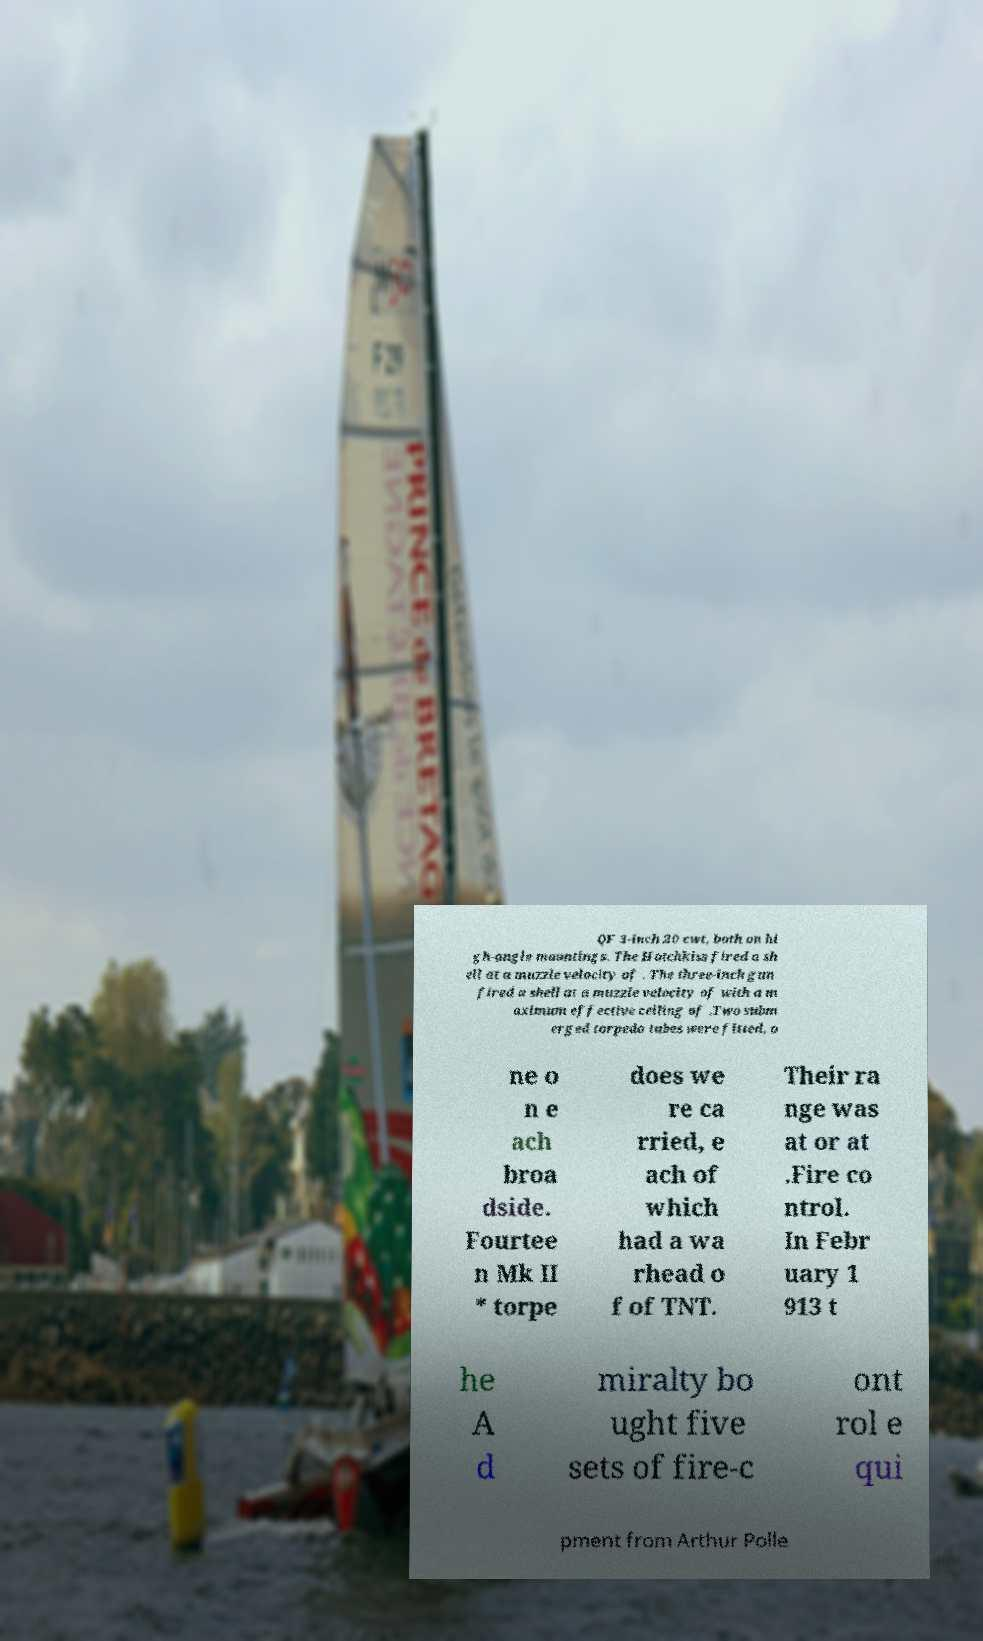I need the written content from this picture converted into text. Can you do that? QF 3-inch 20 cwt, both on hi gh-angle mountings. The Hotchkiss fired a sh ell at a muzzle velocity of . The three-inch gun fired a shell at a muzzle velocity of with a m aximum effective ceiling of .Two subm erged torpedo tubes were fitted, o ne o n e ach broa dside. Fourtee n Mk II * torpe does we re ca rried, e ach of which had a wa rhead o f of TNT. Their ra nge was at or at .Fire co ntrol. In Febr uary 1 913 t he A d miralty bo ught five sets of fire-c ont rol e qui pment from Arthur Polle 